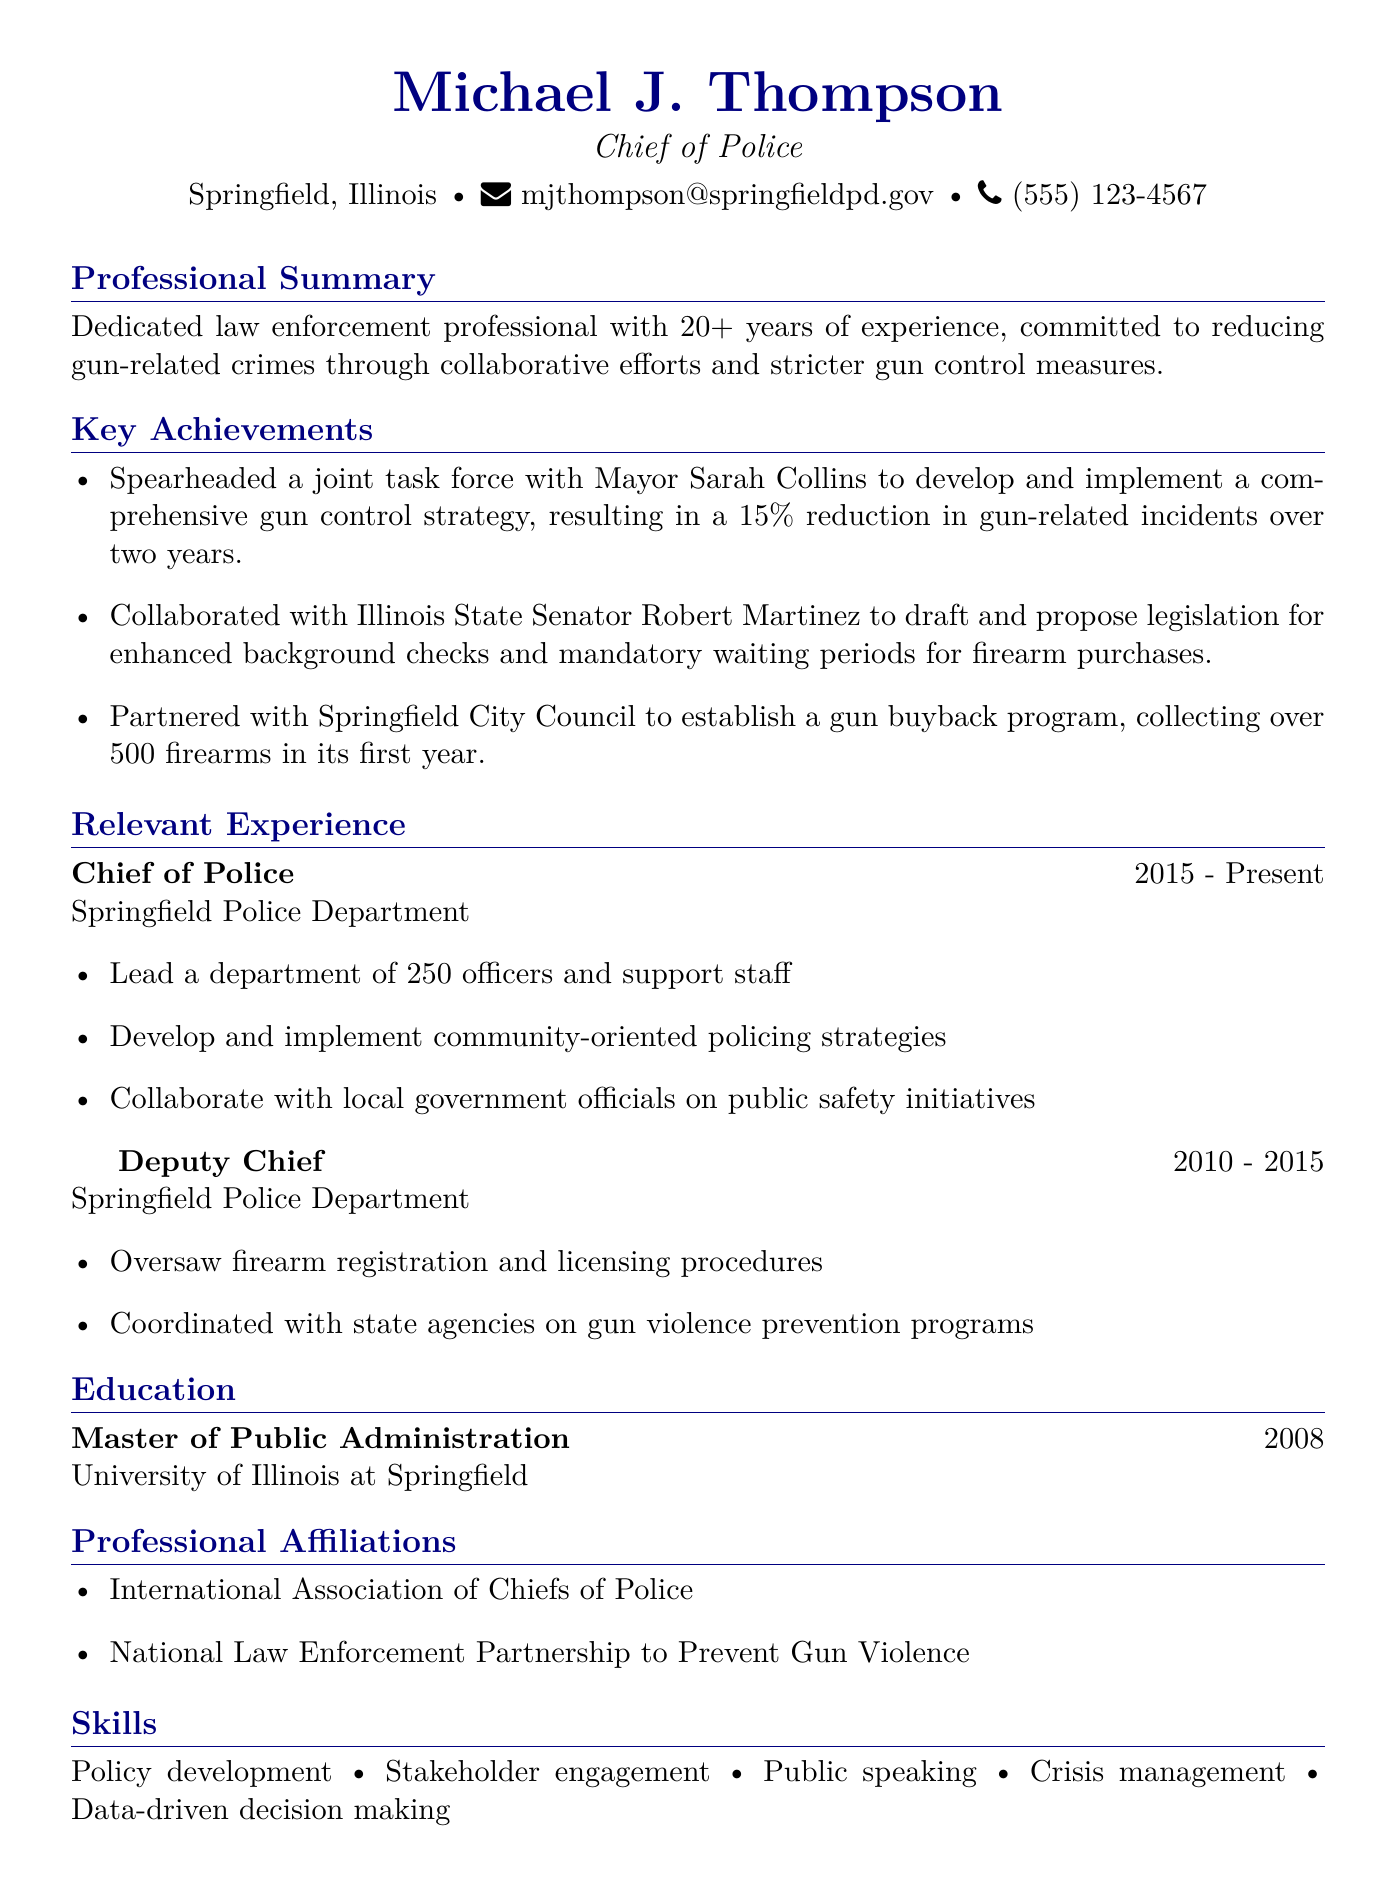What is the name of the Chief of Police? The Chief of Police is identified in the document as Michael J. Thompson.
Answer: Michael J. Thompson What city does Michael J. Thompson serve as Chief of Police? The document states that he serves in Springfield, Illinois.
Answer: Springfield, Illinois How many years of experience does Michael J. Thompson have? The professional summary mentions that he has over 20 years of experience.
Answer: 20+ years What initiative was established in partnership with the Springfield City Council? The document refers to a gun buyback program established with the Springfield City Council.
Answer: Gun buyback program Who did Michael J. Thompson collaborate with to draft legislation for background checks? The document mentions collaboration with Illinois State Senator Robert Martinez for this legislation.
Answer: Robert Martinez What educational degree does Michael J. Thompson hold? The education section states he holds a Master of Public Administration.
Answer: Master of Public Administration In which year did Michael J. Thompson graduate from the University of Illinois at Springfield? The document specifies that he graduated in 2008.
Answer: 2008 What is one key responsibility of Michael J. Thompson as Chief of Police? Among his responsibilities, he leads a department of 250 officers and support staff.
Answer: Lead a department of 250 officers Which professional organization is Michael J. Thompson affiliated with that relates to gun violence prevention? The document lists his affiliation with the National Law Enforcement Partnership to Prevent Gun Violence.
Answer: National Law Enforcement Partnership to Prevent Gun Violence 